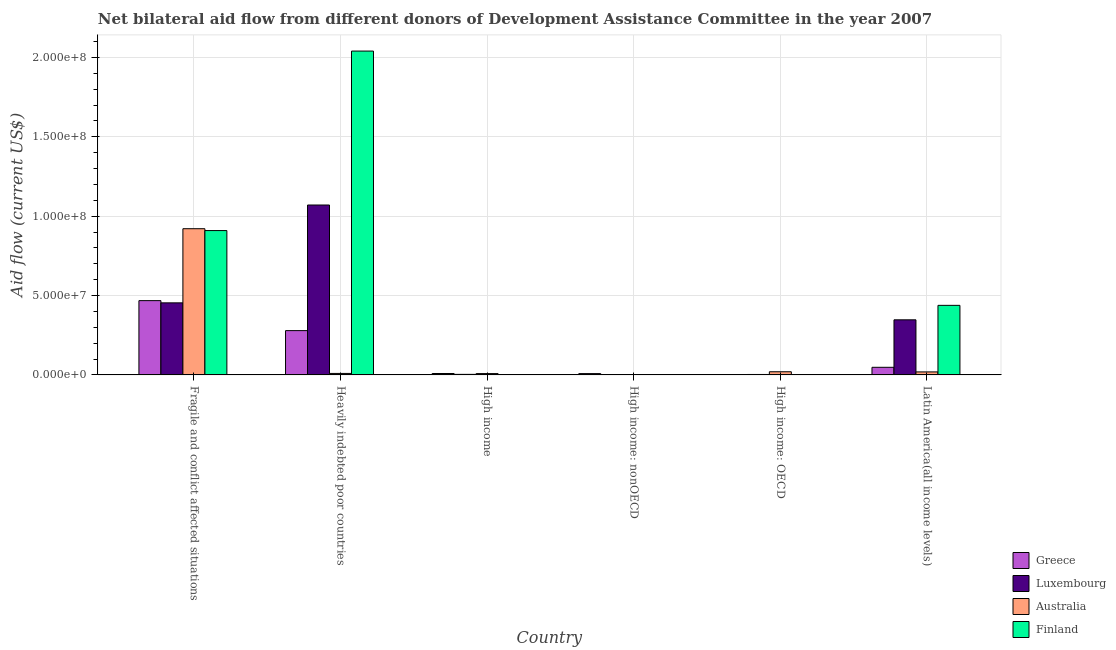Are the number of bars per tick equal to the number of legend labels?
Offer a very short reply. Yes. Are the number of bars on each tick of the X-axis equal?
Offer a terse response. Yes. How many bars are there on the 2nd tick from the left?
Ensure brevity in your answer.  4. What is the label of the 6th group of bars from the left?
Your answer should be compact. Latin America(all income levels). What is the amount of aid given by greece in Heavily indebted poor countries?
Provide a succinct answer. 2.79e+07. Across all countries, what is the maximum amount of aid given by luxembourg?
Keep it short and to the point. 1.07e+08. Across all countries, what is the minimum amount of aid given by greece?
Provide a short and direct response. 5.00e+04. In which country was the amount of aid given by greece maximum?
Offer a terse response. Fragile and conflict affected situations. In which country was the amount of aid given by greece minimum?
Provide a short and direct response. High income: OECD. What is the total amount of aid given by greece in the graph?
Make the answer very short. 8.13e+07. What is the difference between the amount of aid given by luxembourg in Fragile and conflict affected situations and that in High income: OECD?
Your response must be concise. 4.51e+07. What is the difference between the amount of aid given by greece in High income: OECD and the amount of aid given by finland in Fragile and conflict affected situations?
Offer a terse response. -9.09e+07. What is the average amount of aid given by greece per country?
Your response must be concise. 1.35e+07. What is the difference between the amount of aid given by australia and amount of aid given by greece in High income: OECD?
Offer a terse response. 1.94e+06. What is the ratio of the amount of aid given by greece in High income: OECD to that in High income: nonOECD?
Make the answer very short. 0.06. Is the amount of aid given by luxembourg in High income: nonOECD less than that in Latin America(all income levels)?
Your answer should be compact. Yes. Is the difference between the amount of aid given by finland in Fragile and conflict affected situations and High income: nonOECD greater than the difference between the amount of aid given by luxembourg in Fragile and conflict affected situations and High income: nonOECD?
Provide a succinct answer. Yes. What is the difference between the highest and the second highest amount of aid given by australia?
Give a very brief answer. 9.01e+07. What is the difference between the highest and the lowest amount of aid given by australia?
Ensure brevity in your answer.  9.20e+07. In how many countries, is the amount of aid given by greece greater than the average amount of aid given by greece taken over all countries?
Provide a short and direct response. 2. Is the sum of the amount of aid given by luxembourg in Fragile and conflict affected situations and Latin America(all income levels) greater than the maximum amount of aid given by australia across all countries?
Your answer should be compact. No. Is it the case that in every country, the sum of the amount of aid given by greece and amount of aid given by luxembourg is greater than the amount of aid given by australia?
Ensure brevity in your answer.  No. Are the values on the major ticks of Y-axis written in scientific E-notation?
Keep it short and to the point. Yes. Does the graph contain grids?
Provide a succinct answer. Yes. Where does the legend appear in the graph?
Your answer should be very brief. Bottom right. How many legend labels are there?
Provide a succinct answer. 4. What is the title of the graph?
Provide a succinct answer. Net bilateral aid flow from different donors of Development Assistance Committee in the year 2007. What is the label or title of the Y-axis?
Provide a short and direct response. Aid flow (current US$). What is the Aid flow (current US$) of Greece in Fragile and conflict affected situations?
Your response must be concise. 4.68e+07. What is the Aid flow (current US$) of Luxembourg in Fragile and conflict affected situations?
Offer a terse response. 4.54e+07. What is the Aid flow (current US$) of Australia in Fragile and conflict affected situations?
Offer a very short reply. 9.21e+07. What is the Aid flow (current US$) of Finland in Fragile and conflict affected situations?
Your answer should be very brief. 9.09e+07. What is the Aid flow (current US$) of Greece in Heavily indebted poor countries?
Your answer should be very brief. 2.79e+07. What is the Aid flow (current US$) in Luxembourg in Heavily indebted poor countries?
Offer a very short reply. 1.07e+08. What is the Aid flow (current US$) of Australia in Heavily indebted poor countries?
Offer a very short reply. 9.30e+05. What is the Aid flow (current US$) of Finland in Heavily indebted poor countries?
Ensure brevity in your answer.  2.04e+08. What is the Aid flow (current US$) of Greece in High income?
Your answer should be very brief. 8.80e+05. What is the Aid flow (current US$) in Luxembourg in High income?
Provide a succinct answer. 3.40e+05. What is the Aid flow (current US$) of Australia in High income?
Provide a short and direct response. 8.40e+05. What is the Aid flow (current US$) of Greece in High income: nonOECD?
Provide a short and direct response. 8.30e+05. What is the Aid flow (current US$) of Luxembourg in High income: nonOECD?
Make the answer very short. 7.00e+04. What is the Aid flow (current US$) of Australia in High income: OECD?
Offer a terse response. 1.99e+06. What is the Aid flow (current US$) in Finland in High income: OECD?
Your answer should be compact. 1.70e+05. What is the Aid flow (current US$) in Greece in Latin America(all income levels)?
Ensure brevity in your answer.  4.79e+06. What is the Aid flow (current US$) of Luxembourg in Latin America(all income levels)?
Keep it short and to the point. 3.47e+07. What is the Aid flow (current US$) of Australia in Latin America(all income levels)?
Provide a short and direct response. 1.89e+06. What is the Aid flow (current US$) of Finland in Latin America(all income levels)?
Your answer should be very brief. 4.38e+07. Across all countries, what is the maximum Aid flow (current US$) in Greece?
Your response must be concise. 4.68e+07. Across all countries, what is the maximum Aid flow (current US$) of Luxembourg?
Give a very brief answer. 1.07e+08. Across all countries, what is the maximum Aid flow (current US$) of Australia?
Provide a succinct answer. 9.21e+07. Across all countries, what is the maximum Aid flow (current US$) of Finland?
Offer a very short reply. 2.04e+08. Across all countries, what is the minimum Aid flow (current US$) of Finland?
Give a very brief answer. 6.00e+04. What is the total Aid flow (current US$) of Greece in the graph?
Your answer should be very brief. 8.13e+07. What is the total Aid flow (current US$) in Luxembourg in the graph?
Offer a terse response. 1.88e+08. What is the total Aid flow (current US$) in Australia in the graph?
Provide a short and direct response. 9.78e+07. What is the total Aid flow (current US$) of Finland in the graph?
Provide a short and direct response. 3.39e+08. What is the difference between the Aid flow (current US$) of Greece in Fragile and conflict affected situations and that in Heavily indebted poor countries?
Give a very brief answer. 1.89e+07. What is the difference between the Aid flow (current US$) of Luxembourg in Fragile and conflict affected situations and that in Heavily indebted poor countries?
Offer a terse response. -6.16e+07. What is the difference between the Aid flow (current US$) in Australia in Fragile and conflict affected situations and that in Heavily indebted poor countries?
Your answer should be very brief. 9.12e+07. What is the difference between the Aid flow (current US$) in Finland in Fragile and conflict affected situations and that in Heavily indebted poor countries?
Ensure brevity in your answer.  -1.13e+08. What is the difference between the Aid flow (current US$) in Greece in Fragile and conflict affected situations and that in High income?
Give a very brief answer. 4.59e+07. What is the difference between the Aid flow (current US$) of Luxembourg in Fragile and conflict affected situations and that in High income?
Ensure brevity in your answer.  4.51e+07. What is the difference between the Aid flow (current US$) of Australia in Fragile and conflict affected situations and that in High income?
Give a very brief answer. 9.13e+07. What is the difference between the Aid flow (current US$) in Finland in Fragile and conflict affected situations and that in High income?
Ensure brevity in your answer.  9.07e+07. What is the difference between the Aid flow (current US$) of Greece in Fragile and conflict affected situations and that in High income: nonOECD?
Ensure brevity in your answer.  4.60e+07. What is the difference between the Aid flow (current US$) in Luxembourg in Fragile and conflict affected situations and that in High income: nonOECD?
Keep it short and to the point. 4.53e+07. What is the difference between the Aid flow (current US$) of Australia in Fragile and conflict affected situations and that in High income: nonOECD?
Provide a short and direct response. 9.20e+07. What is the difference between the Aid flow (current US$) of Finland in Fragile and conflict affected situations and that in High income: nonOECD?
Ensure brevity in your answer.  9.09e+07. What is the difference between the Aid flow (current US$) of Greece in Fragile and conflict affected situations and that in High income: OECD?
Your answer should be very brief. 4.68e+07. What is the difference between the Aid flow (current US$) of Luxembourg in Fragile and conflict affected situations and that in High income: OECD?
Ensure brevity in your answer.  4.51e+07. What is the difference between the Aid flow (current US$) in Australia in Fragile and conflict affected situations and that in High income: OECD?
Your response must be concise. 9.01e+07. What is the difference between the Aid flow (current US$) in Finland in Fragile and conflict affected situations and that in High income: OECD?
Ensure brevity in your answer.  9.08e+07. What is the difference between the Aid flow (current US$) of Greece in Fragile and conflict affected situations and that in Latin America(all income levels)?
Ensure brevity in your answer.  4.20e+07. What is the difference between the Aid flow (current US$) of Luxembourg in Fragile and conflict affected situations and that in Latin America(all income levels)?
Ensure brevity in your answer.  1.07e+07. What is the difference between the Aid flow (current US$) in Australia in Fragile and conflict affected situations and that in Latin America(all income levels)?
Provide a short and direct response. 9.02e+07. What is the difference between the Aid flow (current US$) in Finland in Fragile and conflict affected situations and that in Latin America(all income levels)?
Give a very brief answer. 4.71e+07. What is the difference between the Aid flow (current US$) in Greece in Heavily indebted poor countries and that in High income?
Your answer should be compact. 2.70e+07. What is the difference between the Aid flow (current US$) in Luxembourg in Heavily indebted poor countries and that in High income?
Offer a terse response. 1.07e+08. What is the difference between the Aid flow (current US$) in Finland in Heavily indebted poor countries and that in High income?
Keep it short and to the point. 2.04e+08. What is the difference between the Aid flow (current US$) of Greece in Heavily indebted poor countries and that in High income: nonOECD?
Offer a terse response. 2.71e+07. What is the difference between the Aid flow (current US$) in Luxembourg in Heavily indebted poor countries and that in High income: nonOECD?
Offer a very short reply. 1.07e+08. What is the difference between the Aid flow (current US$) of Australia in Heavily indebted poor countries and that in High income: nonOECD?
Offer a terse response. 8.40e+05. What is the difference between the Aid flow (current US$) of Finland in Heavily indebted poor countries and that in High income: nonOECD?
Ensure brevity in your answer.  2.04e+08. What is the difference between the Aid flow (current US$) of Greece in Heavily indebted poor countries and that in High income: OECD?
Ensure brevity in your answer.  2.79e+07. What is the difference between the Aid flow (current US$) in Luxembourg in Heavily indebted poor countries and that in High income: OECD?
Keep it short and to the point. 1.07e+08. What is the difference between the Aid flow (current US$) in Australia in Heavily indebted poor countries and that in High income: OECD?
Provide a short and direct response. -1.06e+06. What is the difference between the Aid flow (current US$) in Finland in Heavily indebted poor countries and that in High income: OECD?
Your response must be concise. 2.04e+08. What is the difference between the Aid flow (current US$) of Greece in Heavily indebted poor countries and that in Latin America(all income levels)?
Your response must be concise. 2.31e+07. What is the difference between the Aid flow (current US$) of Luxembourg in Heavily indebted poor countries and that in Latin America(all income levels)?
Make the answer very short. 7.23e+07. What is the difference between the Aid flow (current US$) in Australia in Heavily indebted poor countries and that in Latin America(all income levels)?
Provide a succinct answer. -9.60e+05. What is the difference between the Aid flow (current US$) of Finland in Heavily indebted poor countries and that in Latin America(all income levels)?
Ensure brevity in your answer.  1.60e+08. What is the difference between the Aid flow (current US$) of Greece in High income and that in High income: nonOECD?
Your answer should be compact. 5.00e+04. What is the difference between the Aid flow (current US$) of Australia in High income and that in High income: nonOECD?
Your response must be concise. 7.50e+05. What is the difference between the Aid flow (current US$) of Greece in High income and that in High income: OECD?
Ensure brevity in your answer.  8.30e+05. What is the difference between the Aid flow (current US$) of Luxembourg in High income and that in High income: OECD?
Your response must be concise. 7.00e+04. What is the difference between the Aid flow (current US$) of Australia in High income and that in High income: OECD?
Provide a succinct answer. -1.15e+06. What is the difference between the Aid flow (current US$) in Greece in High income and that in Latin America(all income levels)?
Offer a very short reply. -3.91e+06. What is the difference between the Aid flow (current US$) in Luxembourg in High income and that in Latin America(all income levels)?
Offer a very short reply. -3.44e+07. What is the difference between the Aid flow (current US$) of Australia in High income and that in Latin America(all income levels)?
Offer a very short reply. -1.05e+06. What is the difference between the Aid flow (current US$) of Finland in High income and that in Latin America(all income levels)?
Your answer should be very brief. -4.36e+07. What is the difference between the Aid flow (current US$) in Greece in High income: nonOECD and that in High income: OECD?
Your response must be concise. 7.80e+05. What is the difference between the Aid flow (current US$) of Australia in High income: nonOECD and that in High income: OECD?
Ensure brevity in your answer.  -1.90e+06. What is the difference between the Aid flow (current US$) in Finland in High income: nonOECD and that in High income: OECD?
Provide a short and direct response. -1.10e+05. What is the difference between the Aid flow (current US$) of Greece in High income: nonOECD and that in Latin America(all income levels)?
Ensure brevity in your answer.  -3.96e+06. What is the difference between the Aid flow (current US$) of Luxembourg in High income: nonOECD and that in Latin America(all income levels)?
Ensure brevity in your answer.  -3.46e+07. What is the difference between the Aid flow (current US$) of Australia in High income: nonOECD and that in Latin America(all income levels)?
Provide a succinct answer. -1.80e+06. What is the difference between the Aid flow (current US$) of Finland in High income: nonOECD and that in Latin America(all income levels)?
Ensure brevity in your answer.  -4.38e+07. What is the difference between the Aid flow (current US$) of Greece in High income: OECD and that in Latin America(all income levels)?
Keep it short and to the point. -4.74e+06. What is the difference between the Aid flow (current US$) in Luxembourg in High income: OECD and that in Latin America(all income levels)?
Provide a short and direct response. -3.44e+07. What is the difference between the Aid flow (current US$) of Australia in High income: OECD and that in Latin America(all income levels)?
Your answer should be very brief. 1.00e+05. What is the difference between the Aid flow (current US$) in Finland in High income: OECD and that in Latin America(all income levels)?
Provide a short and direct response. -4.36e+07. What is the difference between the Aid flow (current US$) of Greece in Fragile and conflict affected situations and the Aid flow (current US$) of Luxembourg in Heavily indebted poor countries?
Your answer should be very brief. -6.02e+07. What is the difference between the Aid flow (current US$) in Greece in Fragile and conflict affected situations and the Aid flow (current US$) in Australia in Heavily indebted poor countries?
Keep it short and to the point. 4.59e+07. What is the difference between the Aid flow (current US$) of Greece in Fragile and conflict affected situations and the Aid flow (current US$) of Finland in Heavily indebted poor countries?
Provide a short and direct response. -1.57e+08. What is the difference between the Aid flow (current US$) of Luxembourg in Fragile and conflict affected situations and the Aid flow (current US$) of Australia in Heavily indebted poor countries?
Your answer should be very brief. 4.45e+07. What is the difference between the Aid flow (current US$) of Luxembourg in Fragile and conflict affected situations and the Aid flow (current US$) of Finland in Heavily indebted poor countries?
Offer a very short reply. -1.59e+08. What is the difference between the Aid flow (current US$) of Australia in Fragile and conflict affected situations and the Aid flow (current US$) of Finland in Heavily indebted poor countries?
Your answer should be compact. -1.12e+08. What is the difference between the Aid flow (current US$) in Greece in Fragile and conflict affected situations and the Aid flow (current US$) in Luxembourg in High income?
Ensure brevity in your answer.  4.65e+07. What is the difference between the Aid flow (current US$) in Greece in Fragile and conflict affected situations and the Aid flow (current US$) in Australia in High income?
Offer a very short reply. 4.60e+07. What is the difference between the Aid flow (current US$) of Greece in Fragile and conflict affected situations and the Aid flow (current US$) of Finland in High income?
Your answer should be compact. 4.66e+07. What is the difference between the Aid flow (current US$) of Luxembourg in Fragile and conflict affected situations and the Aid flow (current US$) of Australia in High income?
Make the answer very short. 4.46e+07. What is the difference between the Aid flow (current US$) of Luxembourg in Fragile and conflict affected situations and the Aid flow (current US$) of Finland in High income?
Provide a short and direct response. 4.52e+07. What is the difference between the Aid flow (current US$) of Australia in Fragile and conflict affected situations and the Aid flow (current US$) of Finland in High income?
Keep it short and to the point. 9.19e+07. What is the difference between the Aid flow (current US$) in Greece in Fragile and conflict affected situations and the Aid flow (current US$) in Luxembourg in High income: nonOECD?
Your answer should be very brief. 4.67e+07. What is the difference between the Aid flow (current US$) of Greece in Fragile and conflict affected situations and the Aid flow (current US$) of Australia in High income: nonOECD?
Offer a terse response. 4.67e+07. What is the difference between the Aid flow (current US$) of Greece in Fragile and conflict affected situations and the Aid flow (current US$) of Finland in High income: nonOECD?
Give a very brief answer. 4.67e+07. What is the difference between the Aid flow (current US$) of Luxembourg in Fragile and conflict affected situations and the Aid flow (current US$) of Australia in High income: nonOECD?
Your answer should be compact. 4.53e+07. What is the difference between the Aid flow (current US$) in Luxembourg in Fragile and conflict affected situations and the Aid flow (current US$) in Finland in High income: nonOECD?
Keep it short and to the point. 4.53e+07. What is the difference between the Aid flow (current US$) in Australia in Fragile and conflict affected situations and the Aid flow (current US$) in Finland in High income: nonOECD?
Your answer should be very brief. 9.20e+07. What is the difference between the Aid flow (current US$) in Greece in Fragile and conflict affected situations and the Aid flow (current US$) in Luxembourg in High income: OECD?
Your answer should be compact. 4.65e+07. What is the difference between the Aid flow (current US$) in Greece in Fragile and conflict affected situations and the Aid flow (current US$) in Australia in High income: OECD?
Provide a succinct answer. 4.48e+07. What is the difference between the Aid flow (current US$) of Greece in Fragile and conflict affected situations and the Aid flow (current US$) of Finland in High income: OECD?
Give a very brief answer. 4.66e+07. What is the difference between the Aid flow (current US$) in Luxembourg in Fragile and conflict affected situations and the Aid flow (current US$) in Australia in High income: OECD?
Offer a very short reply. 4.34e+07. What is the difference between the Aid flow (current US$) of Luxembourg in Fragile and conflict affected situations and the Aid flow (current US$) of Finland in High income: OECD?
Ensure brevity in your answer.  4.52e+07. What is the difference between the Aid flow (current US$) of Australia in Fragile and conflict affected situations and the Aid flow (current US$) of Finland in High income: OECD?
Ensure brevity in your answer.  9.19e+07. What is the difference between the Aid flow (current US$) in Greece in Fragile and conflict affected situations and the Aid flow (current US$) in Luxembourg in Latin America(all income levels)?
Offer a very short reply. 1.21e+07. What is the difference between the Aid flow (current US$) in Greece in Fragile and conflict affected situations and the Aid flow (current US$) in Australia in Latin America(all income levels)?
Make the answer very short. 4.49e+07. What is the difference between the Aid flow (current US$) in Greece in Fragile and conflict affected situations and the Aid flow (current US$) in Finland in Latin America(all income levels)?
Your answer should be compact. 2.98e+06. What is the difference between the Aid flow (current US$) in Luxembourg in Fragile and conflict affected situations and the Aid flow (current US$) in Australia in Latin America(all income levels)?
Offer a very short reply. 4.35e+07. What is the difference between the Aid flow (current US$) in Luxembourg in Fragile and conflict affected situations and the Aid flow (current US$) in Finland in Latin America(all income levels)?
Ensure brevity in your answer.  1.58e+06. What is the difference between the Aid flow (current US$) of Australia in Fragile and conflict affected situations and the Aid flow (current US$) of Finland in Latin America(all income levels)?
Your answer should be very brief. 4.83e+07. What is the difference between the Aid flow (current US$) in Greece in Heavily indebted poor countries and the Aid flow (current US$) in Luxembourg in High income?
Offer a very short reply. 2.76e+07. What is the difference between the Aid flow (current US$) in Greece in Heavily indebted poor countries and the Aid flow (current US$) in Australia in High income?
Provide a succinct answer. 2.71e+07. What is the difference between the Aid flow (current US$) of Greece in Heavily indebted poor countries and the Aid flow (current US$) of Finland in High income?
Your answer should be very brief. 2.77e+07. What is the difference between the Aid flow (current US$) in Luxembourg in Heavily indebted poor countries and the Aid flow (current US$) in Australia in High income?
Provide a short and direct response. 1.06e+08. What is the difference between the Aid flow (current US$) of Luxembourg in Heavily indebted poor countries and the Aid flow (current US$) of Finland in High income?
Ensure brevity in your answer.  1.07e+08. What is the difference between the Aid flow (current US$) in Greece in Heavily indebted poor countries and the Aid flow (current US$) in Luxembourg in High income: nonOECD?
Keep it short and to the point. 2.78e+07. What is the difference between the Aid flow (current US$) in Greece in Heavily indebted poor countries and the Aid flow (current US$) in Australia in High income: nonOECD?
Offer a terse response. 2.78e+07. What is the difference between the Aid flow (current US$) in Greece in Heavily indebted poor countries and the Aid flow (current US$) in Finland in High income: nonOECD?
Offer a terse response. 2.78e+07. What is the difference between the Aid flow (current US$) in Luxembourg in Heavily indebted poor countries and the Aid flow (current US$) in Australia in High income: nonOECD?
Ensure brevity in your answer.  1.07e+08. What is the difference between the Aid flow (current US$) of Luxembourg in Heavily indebted poor countries and the Aid flow (current US$) of Finland in High income: nonOECD?
Keep it short and to the point. 1.07e+08. What is the difference between the Aid flow (current US$) in Australia in Heavily indebted poor countries and the Aid flow (current US$) in Finland in High income: nonOECD?
Provide a succinct answer. 8.70e+05. What is the difference between the Aid flow (current US$) of Greece in Heavily indebted poor countries and the Aid flow (current US$) of Luxembourg in High income: OECD?
Provide a short and direct response. 2.76e+07. What is the difference between the Aid flow (current US$) in Greece in Heavily indebted poor countries and the Aid flow (current US$) in Australia in High income: OECD?
Give a very brief answer. 2.59e+07. What is the difference between the Aid flow (current US$) in Greece in Heavily indebted poor countries and the Aid flow (current US$) in Finland in High income: OECD?
Your response must be concise. 2.77e+07. What is the difference between the Aid flow (current US$) in Luxembourg in Heavily indebted poor countries and the Aid flow (current US$) in Australia in High income: OECD?
Your response must be concise. 1.05e+08. What is the difference between the Aid flow (current US$) in Luxembourg in Heavily indebted poor countries and the Aid flow (current US$) in Finland in High income: OECD?
Your answer should be compact. 1.07e+08. What is the difference between the Aid flow (current US$) in Australia in Heavily indebted poor countries and the Aid flow (current US$) in Finland in High income: OECD?
Offer a very short reply. 7.60e+05. What is the difference between the Aid flow (current US$) in Greece in Heavily indebted poor countries and the Aid flow (current US$) in Luxembourg in Latin America(all income levels)?
Ensure brevity in your answer.  -6.80e+06. What is the difference between the Aid flow (current US$) of Greece in Heavily indebted poor countries and the Aid flow (current US$) of Australia in Latin America(all income levels)?
Keep it short and to the point. 2.60e+07. What is the difference between the Aid flow (current US$) of Greece in Heavily indebted poor countries and the Aid flow (current US$) of Finland in Latin America(all income levels)?
Give a very brief answer. -1.59e+07. What is the difference between the Aid flow (current US$) in Luxembourg in Heavily indebted poor countries and the Aid flow (current US$) in Australia in Latin America(all income levels)?
Provide a short and direct response. 1.05e+08. What is the difference between the Aid flow (current US$) of Luxembourg in Heavily indebted poor countries and the Aid flow (current US$) of Finland in Latin America(all income levels)?
Your answer should be very brief. 6.32e+07. What is the difference between the Aid flow (current US$) in Australia in Heavily indebted poor countries and the Aid flow (current US$) in Finland in Latin America(all income levels)?
Offer a terse response. -4.29e+07. What is the difference between the Aid flow (current US$) in Greece in High income and the Aid flow (current US$) in Luxembourg in High income: nonOECD?
Offer a terse response. 8.10e+05. What is the difference between the Aid flow (current US$) in Greece in High income and the Aid flow (current US$) in Australia in High income: nonOECD?
Provide a short and direct response. 7.90e+05. What is the difference between the Aid flow (current US$) of Greece in High income and the Aid flow (current US$) of Finland in High income: nonOECD?
Your answer should be compact. 8.20e+05. What is the difference between the Aid flow (current US$) of Luxembourg in High income and the Aid flow (current US$) of Australia in High income: nonOECD?
Ensure brevity in your answer.  2.50e+05. What is the difference between the Aid flow (current US$) of Australia in High income and the Aid flow (current US$) of Finland in High income: nonOECD?
Provide a short and direct response. 7.80e+05. What is the difference between the Aid flow (current US$) in Greece in High income and the Aid flow (current US$) in Australia in High income: OECD?
Provide a succinct answer. -1.11e+06. What is the difference between the Aid flow (current US$) in Greece in High income and the Aid flow (current US$) in Finland in High income: OECD?
Provide a short and direct response. 7.10e+05. What is the difference between the Aid flow (current US$) of Luxembourg in High income and the Aid flow (current US$) of Australia in High income: OECD?
Make the answer very short. -1.65e+06. What is the difference between the Aid flow (current US$) of Luxembourg in High income and the Aid flow (current US$) of Finland in High income: OECD?
Your response must be concise. 1.70e+05. What is the difference between the Aid flow (current US$) in Australia in High income and the Aid flow (current US$) in Finland in High income: OECD?
Offer a very short reply. 6.70e+05. What is the difference between the Aid flow (current US$) of Greece in High income and the Aid flow (current US$) of Luxembourg in Latin America(all income levels)?
Your answer should be very brief. -3.38e+07. What is the difference between the Aid flow (current US$) in Greece in High income and the Aid flow (current US$) in Australia in Latin America(all income levels)?
Your response must be concise. -1.01e+06. What is the difference between the Aid flow (current US$) of Greece in High income and the Aid flow (current US$) of Finland in Latin America(all income levels)?
Ensure brevity in your answer.  -4.29e+07. What is the difference between the Aid flow (current US$) in Luxembourg in High income and the Aid flow (current US$) in Australia in Latin America(all income levels)?
Offer a terse response. -1.55e+06. What is the difference between the Aid flow (current US$) of Luxembourg in High income and the Aid flow (current US$) of Finland in Latin America(all income levels)?
Your answer should be very brief. -4.35e+07. What is the difference between the Aid flow (current US$) in Australia in High income and the Aid flow (current US$) in Finland in Latin America(all income levels)?
Offer a terse response. -4.30e+07. What is the difference between the Aid flow (current US$) in Greece in High income: nonOECD and the Aid flow (current US$) in Luxembourg in High income: OECD?
Your answer should be compact. 5.60e+05. What is the difference between the Aid flow (current US$) in Greece in High income: nonOECD and the Aid flow (current US$) in Australia in High income: OECD?
Ensure brevity in your answer.  -1.16e+06. What is the difference between the Aid flow (current US$) of Luxembourg in High income: nonOECD and the Aid flow (current US$) of Australia in High income: OECD?
Offer a terse response. -1.92e+06. What is the difference between the Aid flow (current US$) in Luxembourg in High income: nonOECD and the Aid flow (current US$) in Finland in High income: OECD?
Offer a terse response. -1.00e+05. What is the difference between the Aid flow (current US$) in Australia in High income: nonOECD and the Aid flow (current US$) in Finland in High income: OECD?
Offer a very short reply. -8.00e+04. What is the difference between the Aid flow (current US$) of Greece in High income: nonOECD and the Aid flow (current US$) of Luxembourg in Latin America(all income levels)?
Provide a succinct answer. -3.39e+07. What is the difference between the Aid flow (current US$) in Greece in High income: nonOECD and the Aid flow (current US$) in Australia in Latin America(all income levels)?
Provide a succinct answer. -1.06e+06. What is the difference between the Aid flow (current US$) of Greece in High income: nonOECD and the Aid flow (current US$) of Finland in Latin America(all income levels)?
Offer a terse response. -4.30e+07. What is the difference between the Aid flow (current US$) in Luxembourg in High income: nonOECD and the Aid flow (current US$) in Australia in Latin America(all income levels)?
Give a very brief answer. -1.82e+06. What is the difference between the Aid flow (current US$) of Luxembourg in High income: nonOECD and the Aid flow (current US$) of Finland in Latin America(all income levels)?
Offer a terse response. -4.38e+07. What is the difference between the Aid flow (current US$) of Australia in High income: nonOECD and the Aid flow (current US$) of Finland in Latin America(all income levels)?
Your answer should be very brief. -4.37e+07. What is the difference between the Aid flow (current US$) in Greece in High income: OECD and the Aid flow (current US$) in Luxembourg in Latin America(all income levels)?
Give a very brief answer. -3.47e+07. What is the difference between the Aid flow (current US$) in Greece in High income: OECD and the Aid flow (current US$) in Australia in Latin America(all income levels)?
Make the answer very short. -1.84e+06. What is the difference between the Aid flow (current US$) of Greece in High income: OECD and the Aid flow (current US$) of Finland in Latin America(all income levels)?
Offer a very short reply. -4.38e+07. What is the difference between the Aid flow (current US$) in Luxembourg in High income: OECD and the Aid flow (current US$) in Australia in Latin America(all income levels)?
Your answer should be compact. -1.62e+06. What is the difference between the Aid flow (current US$) of Luxembourg in High income: OECD and the Aid flow (current US$) of Finland in Latin America(all income levels)?
Provide a succinct answer. -4.36e+07. What is the difference between the Aid flow (current US$) in Australia in High income: OECD and the Aid flow (current US$) in Finland in Latin America(all income levels)?
Offer a terse response. -4.18e+07. What is the average Aid flow (current US$) of Greece per country?
Offer a terse response. 1.35e+07. What is the average Aid flow (current US$) in Luxembourg per country?
Your response must be concise. 3.13e+07. What is the average Aid flow (current US$) of Australia per country?
Provide a succinct answer. 1.63e+07. What is the average Aid flow (current US$) in Finland per country?
Provide a succinct answer. 5.65e+07. What is the difference between the Aid flow (current US$) of Greece and Aid flow (current US$) of Luxembourg in Fragile and conflict affected situations?
Give a very brief answer. 1.40e+06. What is the difference between the Aid flow (current US$) in Greece and Aid flow (current US$) in Australia in Fragile and conflict affected situations?
Ensure brevity in your answer.  -4.53e+07. What is the difference between the Aid flow (current US$) in Greece and Aid flow (current US$) in Finland in Fragile and conflict affected situations?
Keep it short and to the point. -4.41e+07. What is the difference between the Aid flow (current US$) in Luxembourg and Aid flow (current US$) in Australia in Fragile and conflict affected situations?
Offer a terse response. -4.67e+07. What is the difference between the Aid flow (current US$) of Luxembourg and Aid flow (current US$) of Finland in Fragile and conflict affected situations?
Make the answer very short. -4.55e+07. What is the difference between the Aid flow (current US$) of Australia and Aid flow (current US$) of Finland in Fragile and conflict affected situations?
Provide a short and direct response. 1.17e+06. What is the difference between the Aid flow (current US$) of Greece and Aid flow (current US$) of Luxembourg in Heavily indebted poor countries?
Your answer should be compact. -7.91e+07. What is the difference between the Aid flow (current US$) of Greece and Aid flow (current US$) of Australia in Heavily indebted poor countries?
Offer a very short reply. 2.70e+07. What is the difference between the Aid flow (current US$) in Greece and Aid flow (current US$) in Finland in Heavily indebted poor countries?
Your answer should be very brief. -1.76e+08. What is the difference between the Aid flow (current US$) of Luxembourg and Aid flow (current US$) of Australia in Heavily indebted poor countries?
Your response must be concise. 1.06e+08. What is the difference between the Aid flow (current US$) of Luxembourg and Aid flow (current US$) of Finland in Heavily indebted poor countries?
Provide a succinct answer. -9.70e+07. What is the difference between the Aid flow (current US$) of Australia and Aid flow (current US$) of Finland in Heavily indebted poor countries?
Your response must be concise. -2.03e+08. What is the difference between the Aid flow (current US$) in Greece and Aid flow (current US$) in Luxembourg in High income?
Give a very brief answer. 5.40e+05. What is the difference between the Aid flow (current US$) in Greece and Aid flow (current US$) in Australia in High income?
Offer a terse response. 4.00e+04. What is the difference between the Aid flow (current US$) of Greece and Aid flow (current US$) of Finland in High income?
Give a very brief answer. 6.50e+05. What is the difference between the Aid flow (current US$) in Luxembourg and Aid flow (current US$) in Australia in High income?
Your answer should be compact. -5.00e+05. What is the difference between the Aid flow (current US$) in Luxembourg and Aid flow (current US$) in Finland in High income?
Offer a very short reply. 1.10e+05. What is the difference between the Aid flow (current US$) in Australia and Aid flow (current US$) in Finland in High income?
Give a very brief answer. 6.10e+05. What is the difference between the Aid flow (current US$) of Greece and Aid flow (current US$) of Luxembourg in High income: nonOECD?
Make the answer very short. 7.60e+05. What is the difference between the Aid flow (current US$) of Greece and Aid flow (current US$) of Australia in High income: nonOECD?
Give a very brief answer. 7.40e+05. What is the difference between the Aid flow (current US$) in Greece and Aid flow (current US$) in Finland in High income: nonOECD?
Offer a very short reply. 7.70e+05. What is the difference between the Aid flow (current US$) in Luxembourg and Aid flow (current US$) in Australia in High income: nonOECD?
Your answer should be very brief. -2.00e+04. What is the difference between the Aid flow (current US$) of Greece and Aid flow (current US$) of Luxembourg in High income: OECD?
Offer a very short reply. -2.20e+05. What is the difference between the Aid flow (current US$) of Greece and Aid flow (current US$) of Australia in High income: OECD?
Your answer should be compact. -1.94e+06. What is the difference between the Aid flow (current US$) of Greece and Aid flow (current US$) of Finland in High income: OECD?
Offer a very short reply. -1.20e+05. What is the difference between the Aid flow (current US$) in Luxembourg and Aid flow (current US$) in Australia in High income: OECD?
Your response must be concise. -1.72e+06. What is the difference between the Aid flow (current US$) of Australia and Aid flow (current US$) of Finland in High income: OECD?
Ensure brevity in your answer.  1.82e+06. What is the difference between the Aid flow (current US$) of Greece and Aid flow (current US$) of Luxembourg in Latin America(all income levels)?
Keep it short and to the point. -2.99e+07. What is the difference between the Aid flow (current US$) in Greece and Aid flow (current US$) in Australia in Latin America(all income levels)?
Your answer should be very brief. 2.90e+06. What is the difference between the Aid flow (current US$) in Greece and Aid flow (current US$) in Finland in Latin America(all income levels)?
Your answer should be very brief. -3.90e+07. What is the difference between the Aid flow (current US$) in Luxembourg and Aid flow (current US$) in Australia in Latin America(all income levels)?
Make the answer very short. 3.28e+07. What is the difference between the Aid flow (current US$) of Luxembourg and Aid flow (current US$) of Finland in Latin America(all income levels)?
Your answer should be compact. -9.11e+06. What is the difference between the Aid flow (current US$) of Australia and Aid flow (current US$) of Finland in Latin America(all income levels)?
Make the answer very short. -4.19e+07. What is the ratio of the Aid flow (current US$) of Greece in Fragile and conflict affected situations to that in Heavily indebted poor countries?
Your answer should be very brief. 1.68. What is the ratio of the Aid flow (current US$) of Luxembourg in Fragile and conflict affected situations to that in Heavily indebted poor countries?
Offer a very short reply. 0.42. What is the ratio of the Aid flow (current US$) in Australia in Fragile and conflict affected situations to that in Heavily indebted poor countries?
Your response must be concise. 99.04. What is the ratio of the Aid flow (current US$) in Finland in Fragile and conflict affected situations to that in Heavily indebted poor countries?
Offer a terse response. 0.45. What is the ratio of the Aid flow (current US$) of Greece in Fragile and conflict affected situations to that in High income?
Your answer should be very brief. 53.18. What is the ratio of the Aid flow (current US$) in Luxembourg in Fragile and conflict affected situations to that in High income?
Provide a short and direct response. 133.53. What is the ratio of the Aid flow (current US$) of Australia in Fragile and conflict affected situations to that in High income?
Offer a terse response. 109.65. What is the ratio of the Aid flow (current US$) in Finland in Fragile and conflict affected situations to that in High income?
Keep it short and to the point. 395.39. What is the ratio of the Aid flow (current US$) in Greece in Fragile and conflict affected situations to that in High income: nonOECD?
Your answer should be very brief. 56.39. What is the ratio of the Aid flow (current US$) in Luxembourg in Fragile and conflict affected situations to that in High income: nonOECD?
Provide a short and direct response. 648.57. What is the ratio of the Aid flow (current US$) in Australia in Fragile and conflict affected situations to that in High income: nonOECD?
Provide a succinct answer. 1023.44. What is the ratio of the Aid flow (current US$) in Finland in Fragile and conflict affected situations to that in High income: nonOECD?
Offer a terse response. 1515.67. What is the ratio of the Aid flow (current US$) of Greece in Fragile and conflict affected situations to that in High income: OECD?
Provide a succinct answer. 936. What is the ratio of the Aid flow (current US$) in Luxembourg in Fragile and conflict affected situations to that in High income: OECD?
Offer a terse response. 168.15. What is the ratio of the Aid flow (current US$) of Australia in Fragile and conflict affected situations to that in High income: OECD?
Your answer should be very brief. 46.29. What is the ratio of the Aid flow (current US$) of Finland in Fragile and conflict affected situations to that in High income: OECD?
Make the answer very short. 534.94. What is the ratio of the Aid flow (current US$) in Greece in Fragile and conflict affected situations to that in Latin America(all income levels)?
Offer a terse response. 9.77. What is the ratio of the Aid flow (current US$) in Luxembourg in Fragile and conflict affected situations to that in Latin America(all income levels)?
Provide a short and direct response. 1.31. What is the ratio of the Aid flow (current US$) in Australia in Fragile and conflict affected situations to that in Latin America(all income levels)?
Ensure brevity in your answer.  48.74. What is the ratio of the Aid flow (current US$) in Finland in Fragile and conflict affected situations to that in Latin America(all income levels)?
Offer a very short reply. 2.08. What is the ratio of the Aid flow (current US$) of Greece in Heavily indebted poor countries to that in High income?
Ensure brevity in your answer.  31.72. What is the ratio of the Aid flow (current US$) of Luxembourg in Heavily indebted poor countries to that in High income?
Make the answer very short. 314.82. What is the ratio of the Aid flow (current US$) of Australia in Heavily indebted poor countries to that in High income?
Make the answer very short. 1.11. What is the ratio of the Aid flow (current US$) in Finland in Heavily indebted poor countries to that in High income?
Keep it short and to the point. 887.09. What is the ratio of the Aid flow (current US$) in Greece in Heavily indebted poor countries to that in High income: nonOECD?
Provide a succinct answer. 33.63. What is the ratio of the Aid flow (current US$) in Luxembourg in Heavily indebted poor countries to that in High income: nonOECD?
Give a very brief answer. 1529.14. What is the ratio of the Aid flow (current US$) of Australia in Heavily indebted poor countries to that in High income: nonOECD?
Provide a short and direct response. 10.33. What is the ratio of the Aid flow (current US$) of Finland in Heavily indebted poor countries to that in High income: nonOECD?
Make the answer very short. 3400.5. What is the ratio of the Aid flow (current US$) of Greece in Heavily indebted poor countries to that in High income: OECD?
Give a very brief answer. 558.2. What is the ratio of the Aid flow (current US$) in Luxembourg in Heavily indebted poor countries to that in High income: OECD?
Make the answer very short. 396.44. What is the ratio of the Aid flow (current US$) in Australia in Heavily indebted poor countries to that in High income: OECD?
Ensure brevity in your answer.  0.47. What is the ratio of the Aid flow (current US$) of Finland in Heavily indebted poor countries to that in High income: OECD?
Keep it short and to the point. 1200.18. What is the ratio of the Aid flow (current US$) in Greece in Heavily indebted poor countries to that in Latin America(all income levels)?
Your response must be concise. 5.83. What is the ratio of the Aid flow (current US$) of Luxembourg in Heavily indebted poor countries to that in Latin America(all income levels)?
Keep it short and to the point. 3.08. What is the ratio of the Aid flow (current US$) in Australia in Heavily indebted poor countries to that in Latin America(all income levels)?
Give a very brief answer. 0.49. What is the ratio of the Aid flow (current US$) in Finland in Heavily indebted poor countries to that in Latin America(all income levels)?
Your response must be concise. 4.66. What is the ratio of the Aid flow (current US$) in Greece in High income to that in High income: nonOECD?
Your response must be concise. 1.06. What is the ratio of the Aid flow (current US$) of Luxembourg in High income to that in High income: nonOECD?
Your response must be concise. 4.86. What is the ratio of the Aid flow (current US$) in Australia in High income to that in High income: nonOECD?
Your answer should be compact. 9.33. What is the ratio of the Aid flow (current US$) of Finland in High income to that in High income: nonOECD?
Make the answer very short. 3.83. What is the ratio of the Aid flow (current US$) of Greece in High income to that in High income: OECD?
Provide a succinct answer. 17.6. What is the ratio of the Aid flow (current US$) in Luxembourg in High income to that in High income: OECD?
Provide a short and direct response. 1.26. What is the ratio of the Aid flow (current US$) of Australia in High income to that in High income: OECD?
Offer a very short reply. 0.42. What is the ratio of the Aid flow (current US$) in Finland in High income to that in High income: OECD?
Provide a succinct answer. 1.35. What is the ratio of the Aid flow (current US$) of Greece in High income to that in Latin America(all income levels)?
Your response must be concise. 0.18. What is the ratio of the Aid flow (current US$) in Luxembourg in High income to that in Latin America(all income levels)?
Your answer should be compact. 0.01. What is the ratio of the Aid flow (current US$) of Australia in High income to that in Latin America(all income levels)?
Your response must be concise. 0.44. What is the ratio of the Aid flow (current US$) in Finland in High income to that in Latin America(all income levels)?
Keep it short and to the point. 0.01. What is the ratio of the Aid flow (current US$) in Luxembourg in High income: nonOECD to that in High income: OECD?
Your answer should be very brief. 0.26. What is the ratio of the Aid flow (current US$) in Australia in High income: nonOECD to that in High income: OECD?
Provide a succinct answer. 0.05. What is the ratio of the Aid flow (current US$) in Finland in High income: nonOECD to that in High income: OECD?
Give a very brief answer. 0.35. What is the ratio of the Aid flow (current US$) of Greece in High income: nonOECD to that in Latin America(all income levels)?
Your response must be concise. 0.17. What is the ratio of the Aid flow (current US$) in Luxembourg in High income: nonOECD to that in Latin America(all income levels)?
Offer a terse response. 0. What is the ratio of the Aid flow (current US$) of Australia in High income: nonOECD to that in Latin America(all income levels)?
Provide a short and direct response. 0.05. What is the ratio of the Aid flow (current US$) of Finland in High income: nonOECD to that in Latin America(all income levels)?
Offer a terse response. 0. What is the ratio of the Aid flow (current US$) of Greece in High income: OECD to that in Latin America(all income levels)?
Make the answer very short. 0.01. What is the ratio of the Aid flow (current US$) in Luxembourg in High income: OECD to that in Latin America(all income levels)?
Your answer should be compact. 0.01. What is the ratio of the Aid flow (current US$) of Australia in High income: OECD to that in Latin America(all income levels)?
Provide a short and direct response. 1.05. What is the ratio of the Aid flow (current US$) of Finland in High income: OECD to that in Latin America(all income levels)?
Offer a very short reply. 0. What is the difference between the highest and the second highest Aid flow (current US$) of Greece?
Make the answer very short. 1.89e+07. What is the difference between the highest and the second highest Aid flow (current US$) of Luxembourg?
Make the answer very short. 6.16e+07. What is the difference between the highest and the second highest Aid flow (current US$) in Australia?
Provide a short and direct response. 9.01e+07. What is the difference between the highest and the second highest Aid flow (current US$) in Finland?
Give a very brief answer. 1.13e+08. What is the difference between the highest and the lowest Aid flow (current US$) in Greece?
Your response must be concise. 4.68e+07. What is the difference between the highest and the lowest Aid flow (current US$) in Luxembourg?
Your response must be concise. 1.07e+08. What is the difference between the highest and the lowest Aid flow (current US$) in Australia?
Offer a terse response. 9.20e+07. What is the difference between the highest and the lowest Aid flow (current US$) in Finland?
Offer a terse response. 2.04e+08. 